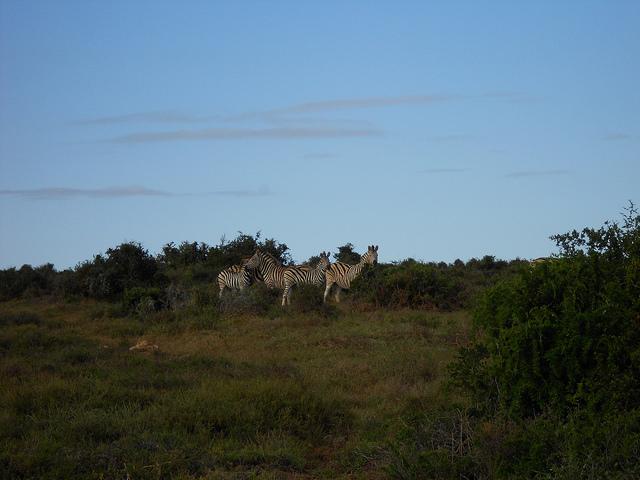What animal is in the image?
Short answer required. Zebra. Is the animal in this picture near or far?
Answer briefly. Far. What plant is shown?
Be succinct. Grass. What kind of animals are in the field?
Keep it brief. Zebras. Is there a kite in the sky?
Short answer required. No. Is the sky overcast?
Concise answer only. No. How many types of animals are there?
Quick response, please. 1. What is the weather?
Quick response, please. Clear. What time of day is it?
Answer briefly. Noon. What is the animal?
Quick response, please. Zebra. Are these giraffes all the same height?
Keep it brief. No. What are the zebras standing on?
Answer briefly. Grass. What time was the picture taken?
Keep it brief. Dusk. Is it daytime?
Answer briefly. Yes. Where are the animals?
Concise answer only. Field. What are these animals?
Keep it brief. Zebras. How many roads are there?
Give a very brief answer. 0. What are the lines in the sky?
Be succinct. Clouds. What kind of clouds are in the sky?
Short answer required. Long. What are the animals in the picture?
Write a very short answer. Zebras. What is the predominant color of this animal's fur?
Concise answer only. White. 